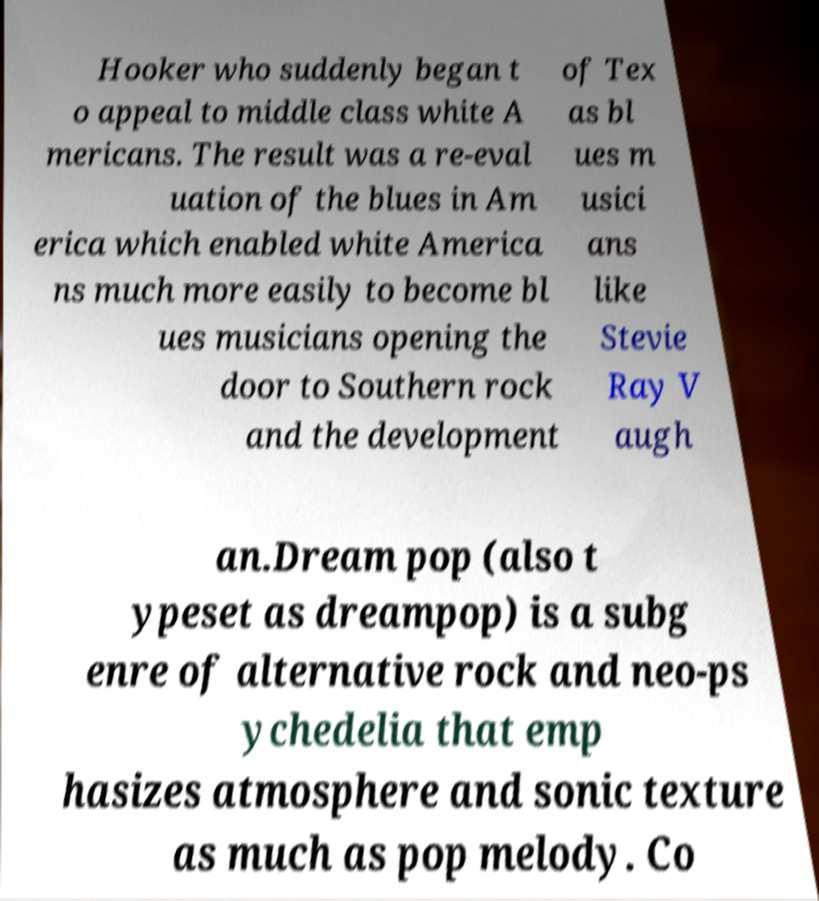I need the written content from this picture converted into text. Can you do that? Hooker who suddenly began t o appeal to middle class white A mericans. The result was a re-eval uation of the blues in Am erica which enabled white America ns much more easily to become bl ues musicians opening the door to Southern rock and the development of Tex as bl ues m usici ans like Stevie Ray V augh an.Dream pop (also t ypeset as dreampop) is a subg enre of alternative rock and neo-ps ychedelia that emp hasizes atmosphere and sonic texture as much as pop melody. Co 